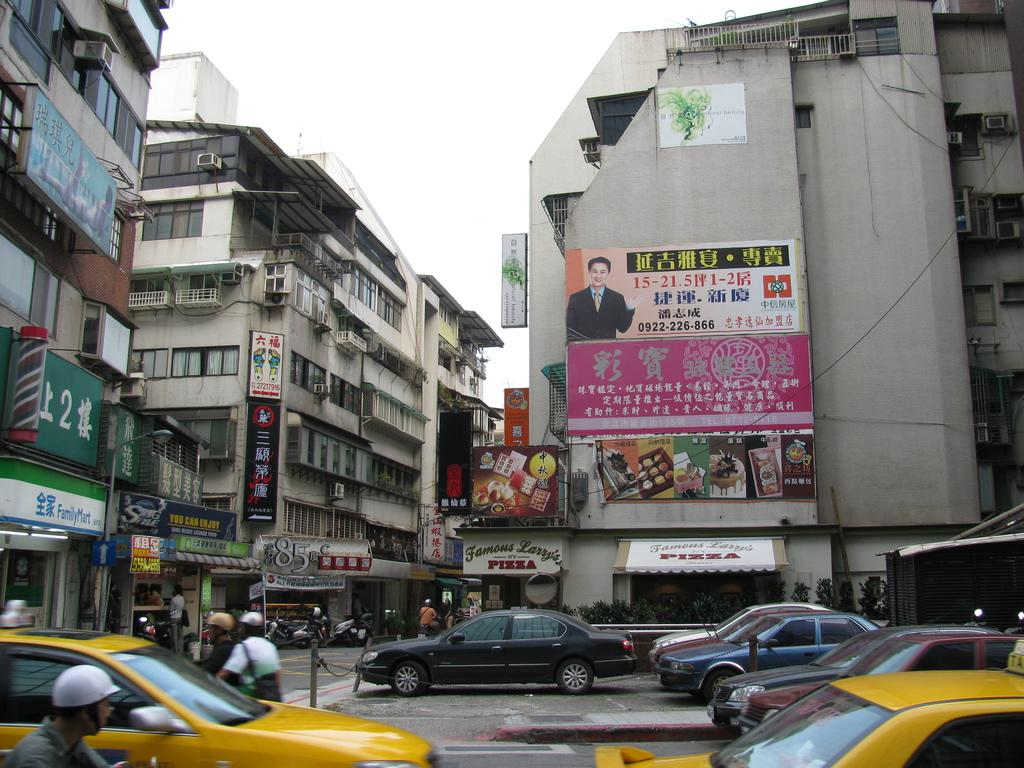Provide a one-sentence caption for the provided image. A busy street with a billboard that is in Chinese with the numbers 0922-226-866 on it. 